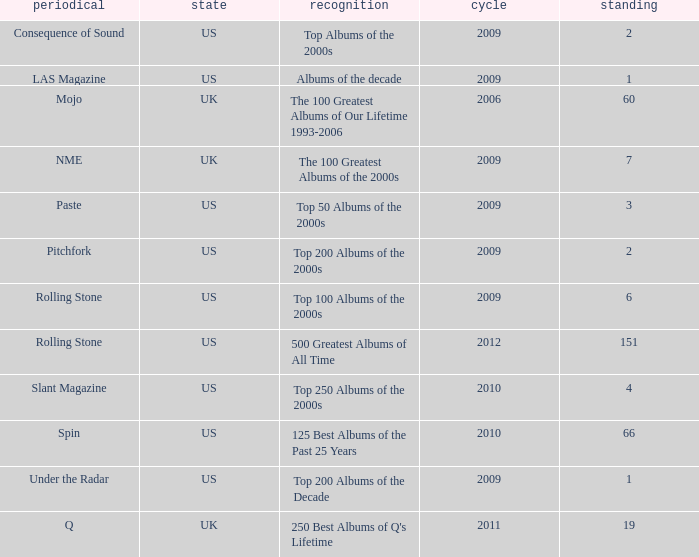What was the lowest rank after 2009 with an accolade of 125 best albums of the past 25 years? 66.0. 